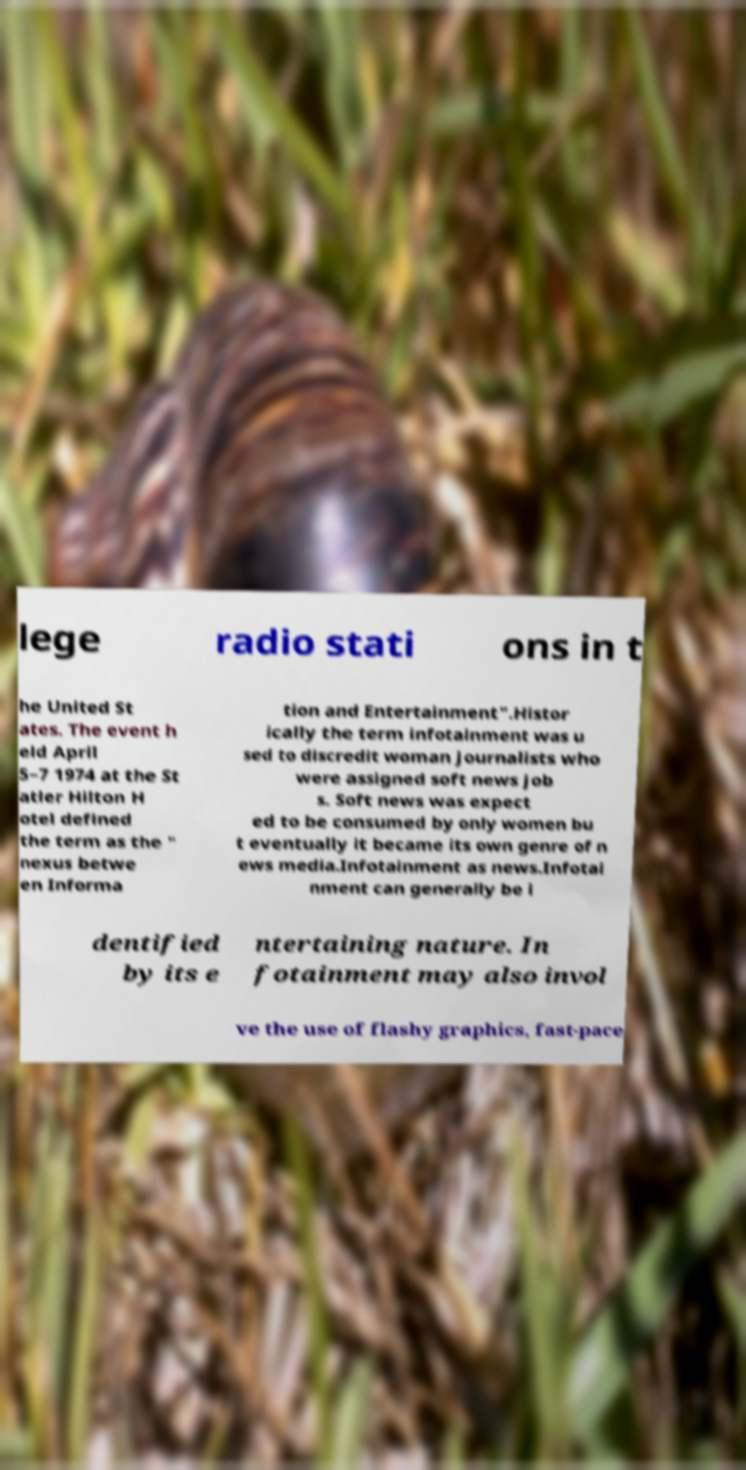For documentation purposes, I need the text within this image transcribed. Could you provide that? lege radio stati ons in t he United St ates. The event h eld April 5–7 1974 at the St atler Hilton H otel defined the term as the " nexus betwe en Informa tion and Entertainment".Histor ically the term infotainment was u sed to discredit woman journalists who were assigned soft news job s. Soft news was expect ed to be consumed by only women bu t eventually it became its own genre of n ews media.Infotainment as news.Infotai nment can generally be i dentified by its e ntertaining nature. In fotainment may also invol ve the use of flashy graphics, fast-pace 